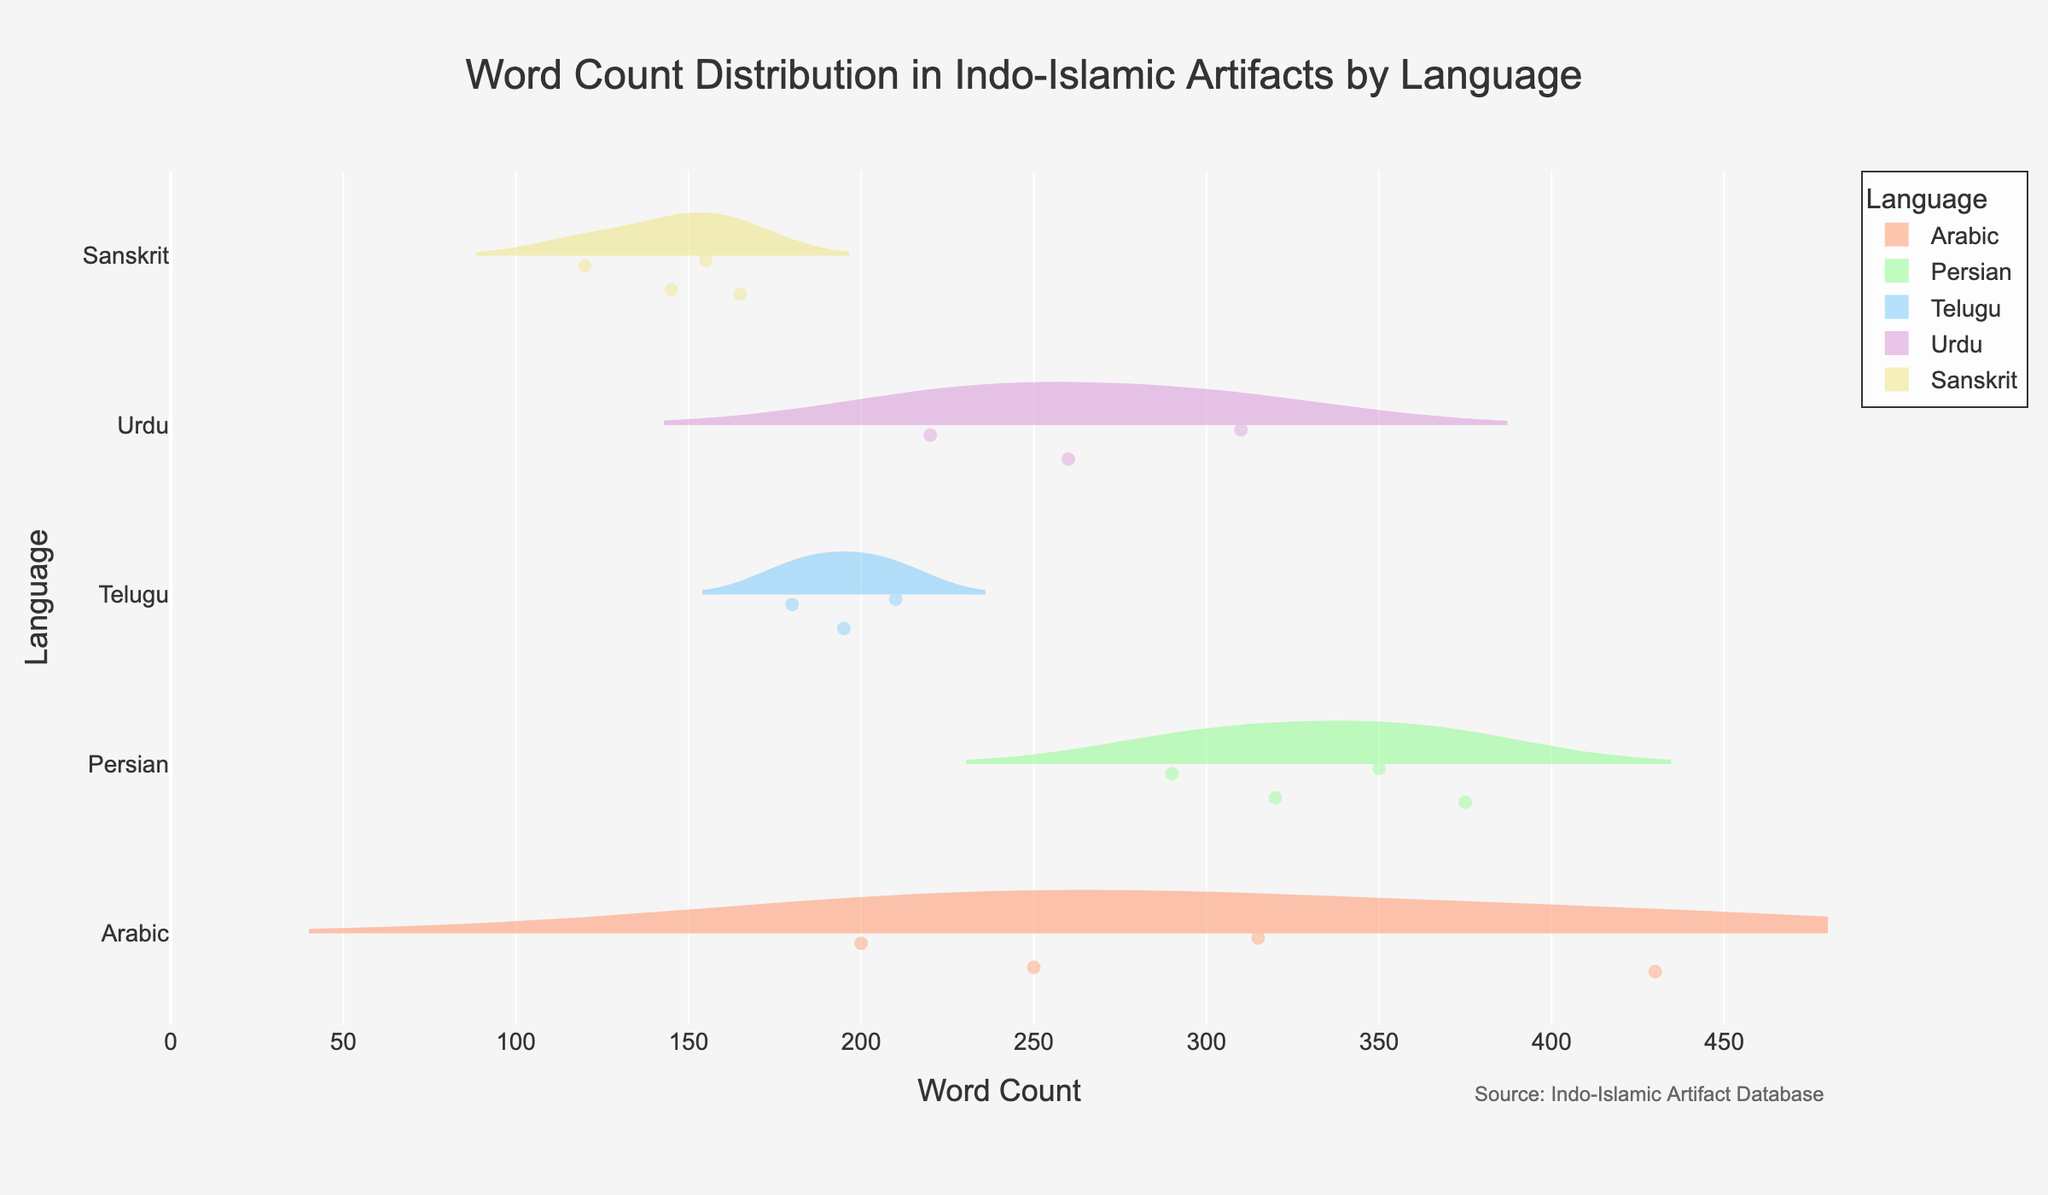What is the title of the figure? The title is displayed at the top of the figure. It helps set the context for the viewer about what the plot represents.
Answer: Word Count Distribution in Indo-Islamic Artifacts by Language Which language has the highest word count in an artifact? Look at the violin plot for the maximum horizontal spread. Identify which language corresponds to that higher count and refer to the top word count.
Answer: Arabic How many languages are represented in the figure? Count the unique categories on the y-axis of the violin plot. Each represents a different language.
Answer: 5 What is the average word count for artifacts inscribed in Sanskrit? Calculate the mean by summing all word counts for Sanskrit and dividing by the number of Sanskrit data points: (145 + 165 + 120 + 155) / 4.
Answer: 146.25 Which language has the most varied word count based on the spread of the violin plots? Compare the width of the violin plots for each language. The language with the widest plot has the most varied word count.
Answer: Persian Is the word count distribution more spread out for Urdu or Telugu artifacts? Compare the horizontal spread of the violin plots for Urdu and Telugu. The one with a broader shape indicates more spread out distribution.
Answer: Urdu What is the median word count for artifacts inscribed in Arabic? Look at the mean line within the violin plot; it often includes the median value.
Answer: Around 250 How does the maximum word count for Persian compare to that of Telugu? Locate the highest point in the Persian and Telugu plots and compare their end points.
Answer: Persian word count is higher Which language appears to have the highest density of artifacts with word counts around 300? Observe the violin plots to see which one has the thickest concentration around the 300 mark.
Answer: Persian Are there any artifacts with a word count less than 150? Check the violin plots to see if any extend below the 150 word count mark.
Answer: Yes 